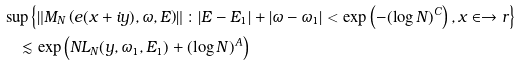Convert formula to latex. <formula><loc_0><loc_0><loc_500><loc_500>& \sup \left \{ \left \| M _ { N } \left ( e ( x + i y ) , \omega , E \right ) \right \| \colon | E - E _ { 1 } | + | \omega - \omega _ { 1 } | < \exp \left ( - ( \log N ) ^ { C } \right ) , x \in \to r \right \} \\ & \quad \lesssim \exp \left ( N L _ { N } ( y , \omega _ { 1 } , E _ { 1 } ) + ( \log N ) ^ { A } \right )</formula> 